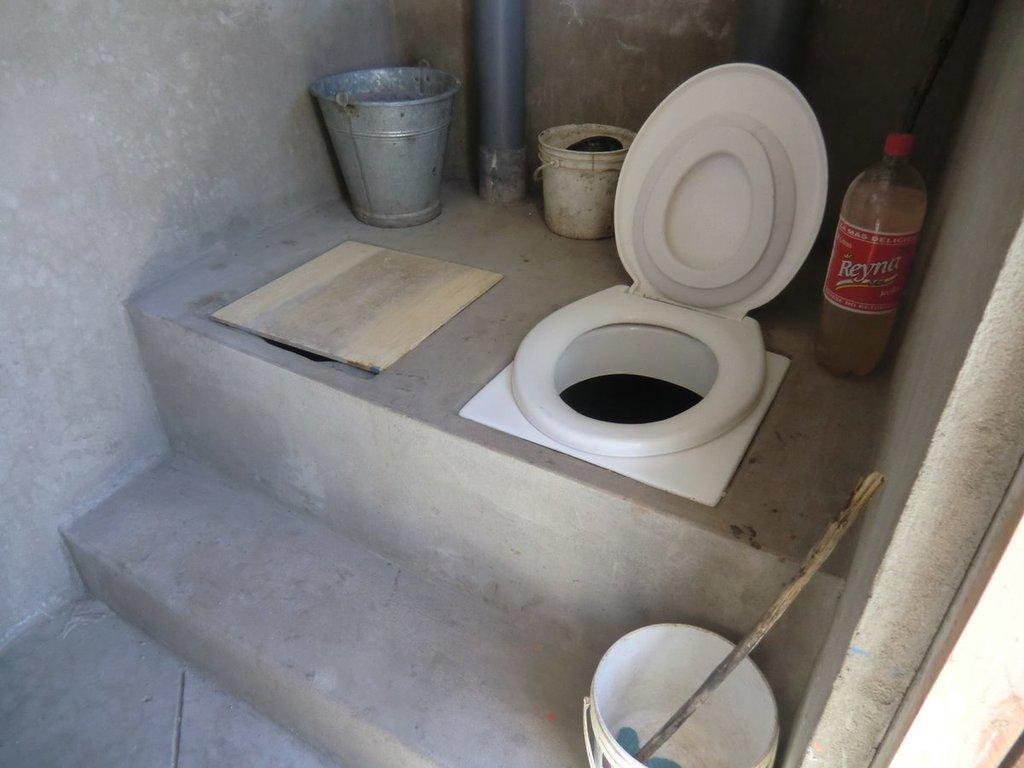Please provide a concise description of this image. In this image we can see a toilet. We can also see some buckets, a wooden board and a bottle beside it. 